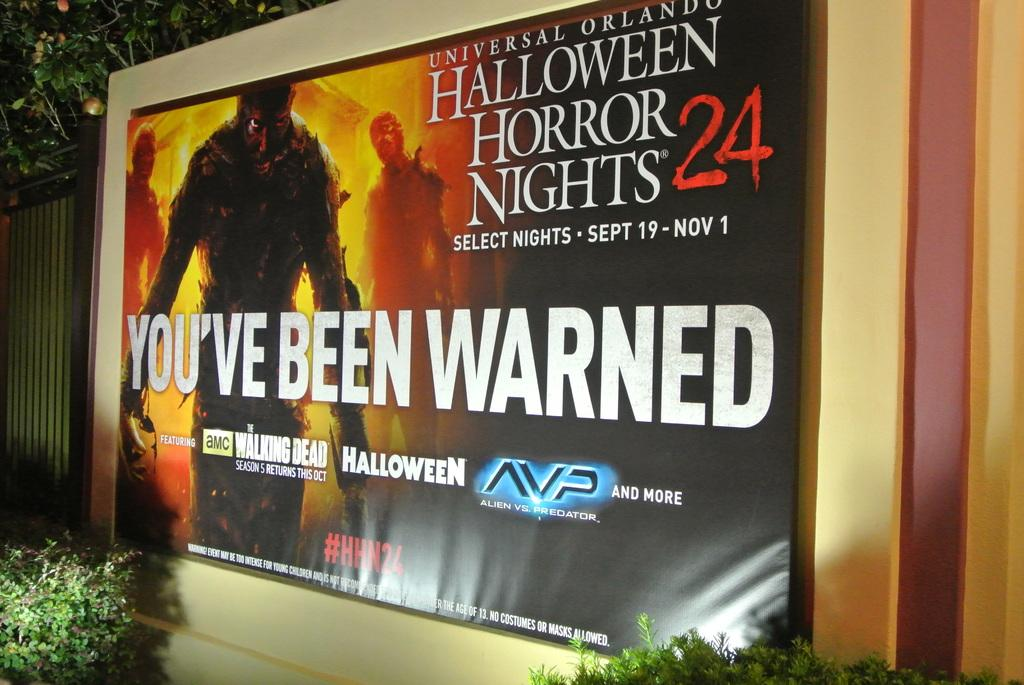<image>
Relay a brief, clear account of the picture shown. An outdoor poster promotes a Halloween event at Universal Orlando. 